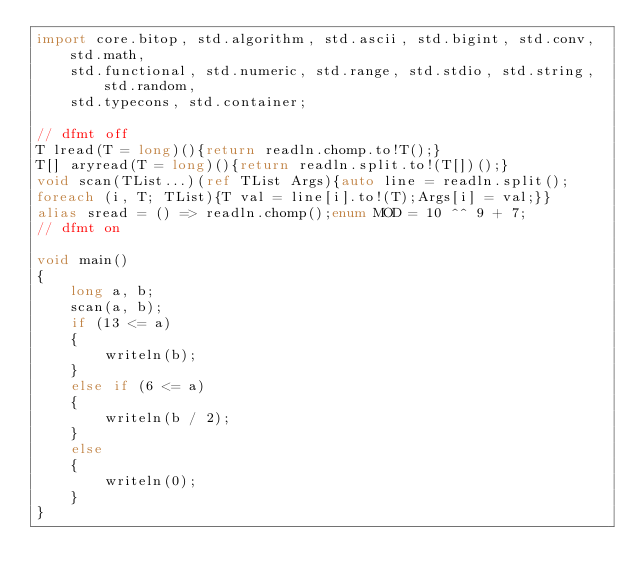Convert code to text. <code><loc_0><loc_0><loc_500><loc_500><_D_>import core.bitop, std.algorithm, std.ascii, std.bigint, std.conv, std.math,
    std.functional, std.numeric, std.range, std.stdio, std.string, std.random,
    std.typecons, std.container;

// dfmt off
T lread(T = long)(){return readln.chomp.to!T();}
T[] aryread(T = long)(){return readln.split.to!(T[])();}
void scan(TList...)(ref TList Args){auto line = readln.split();
foreach (i, T; TList){T val = line[i].to!(T);Args[i] = val;}}
alias sread = () => readln.chomp();enum MOD = 10 ^^ 9 + 7;
// dfmt on

void main()
{
    long a, b;
    scan(a, b);
    if (13 <= a)
    {
        writeln(b);
    }
    else if (6 <= a)
    {
        writeln(b / 2);
    }
    else
    {
        writeln(0);
    }
}
</code> 